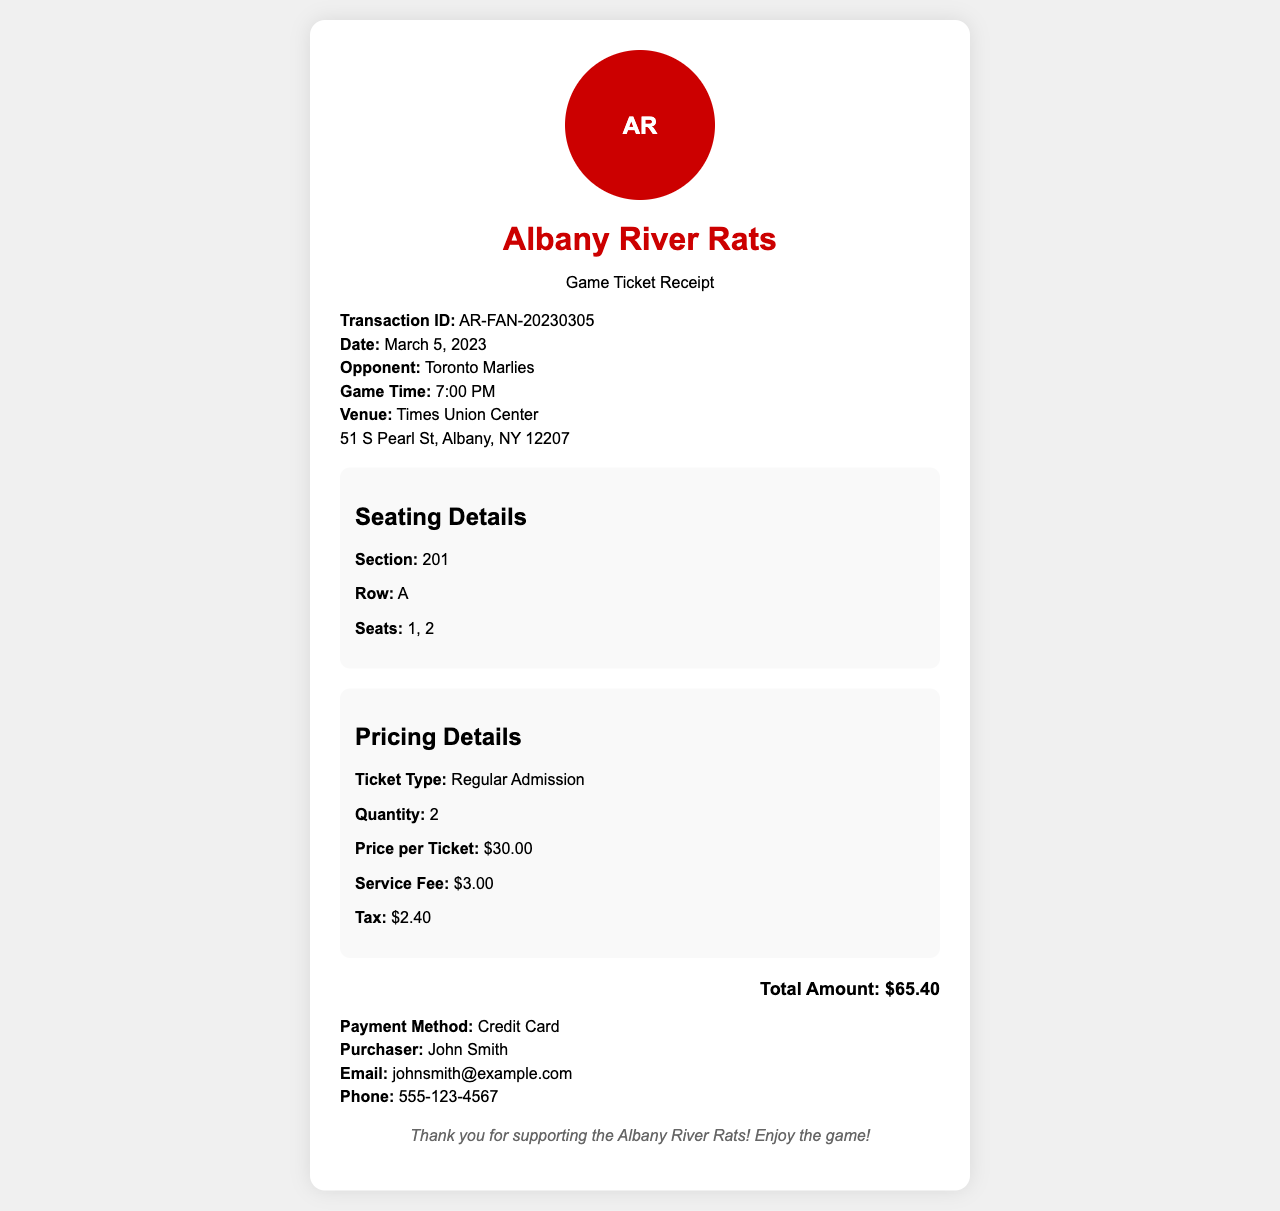What is the transaction ID? The transaction ID is a unique identifier for the ticket purchase, which is AR-FAN-20230305.
Answer: AR-FAN-20230305 What is the game time? The game time indicates when the match will start, which is 7:00 PM.
Answer: 7:00 PM How many tickets were purchased? The quantity of tickets purchased is given in the document, which is 2.
Answer: 2 What is the price per ticket? The price per ticket is listed in the pricing details, which is $30.00.
Answer: $30.00 What is the total amount? The total amount is the final cost of the tickets plus fees and tax, recorded as $65.40.
Answer: $65.40 In which section are the seats located? The seating details specify the section for the seats, which is 201.
Answer: 201 What type of payment was used? The payment method indicates how the transaction was completed, which is Credit Card.
Answer: Credit Card Who is the purchaser? The purchaser's name is stated in the document, which is John Smith.
Answer: John Smith What opponent did the Albany River Rats face? The opponent for the game on the specified date is mentioned in the details, which is Toronto Marlies.
Answer: Toronto Marlies 